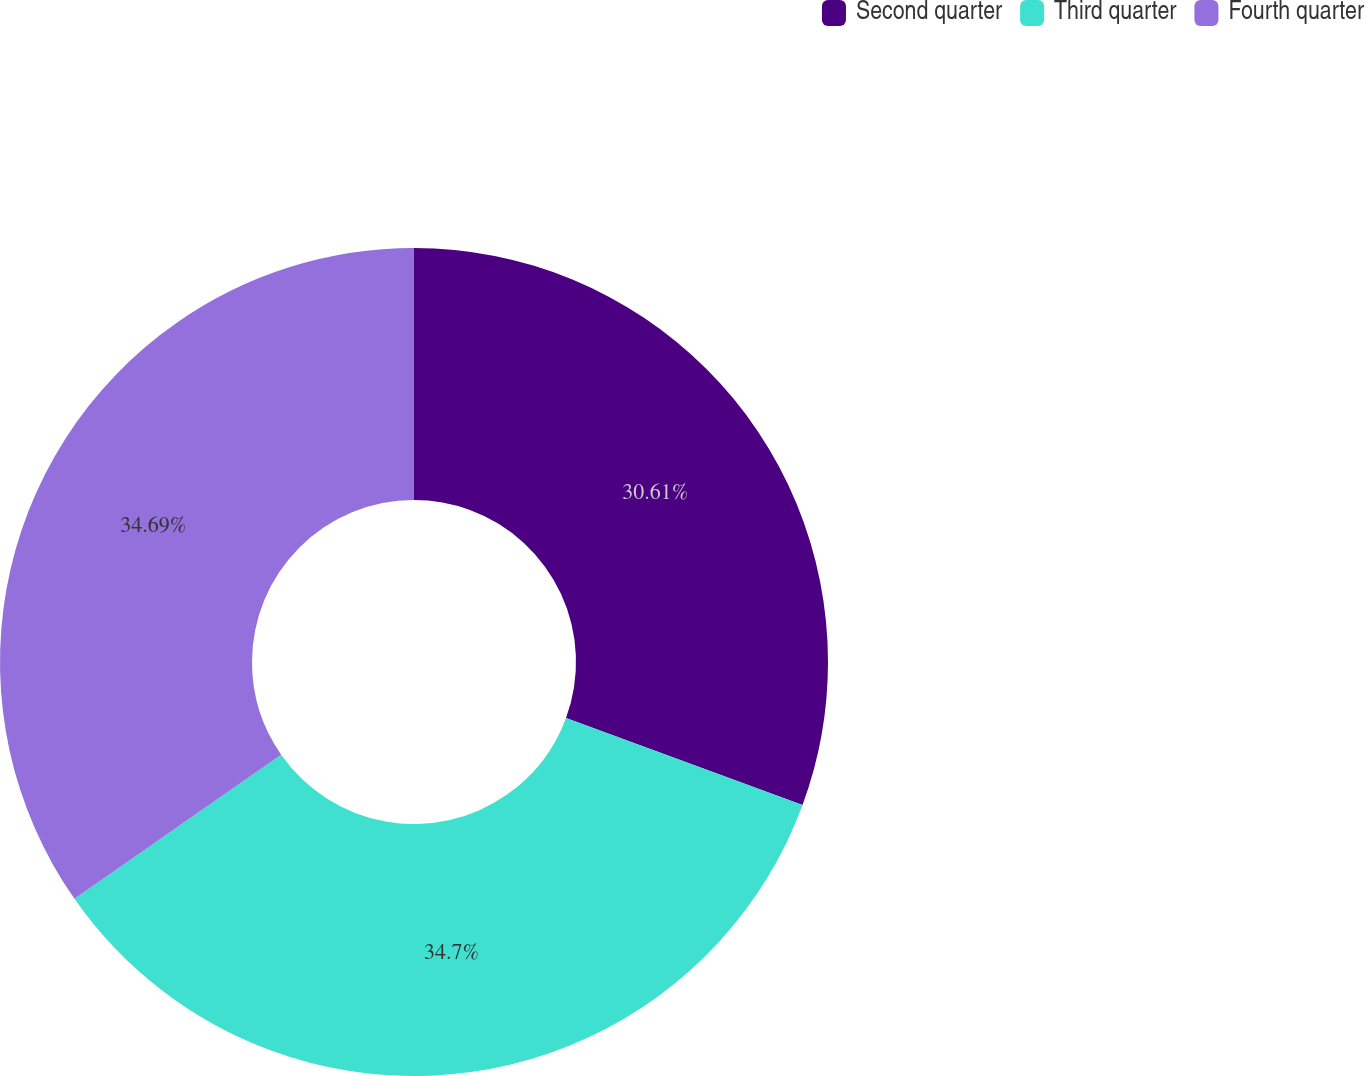Convert chart. <chart><loc_0><loc_0><loc_500><loc_500><pie_chart><fcel>Second quarter<fcel>Third quarter<fcel>Fourth quarter<nl><fcel>30.61%<fcel>34.69%<fcel>34.69%<nl></chart> 